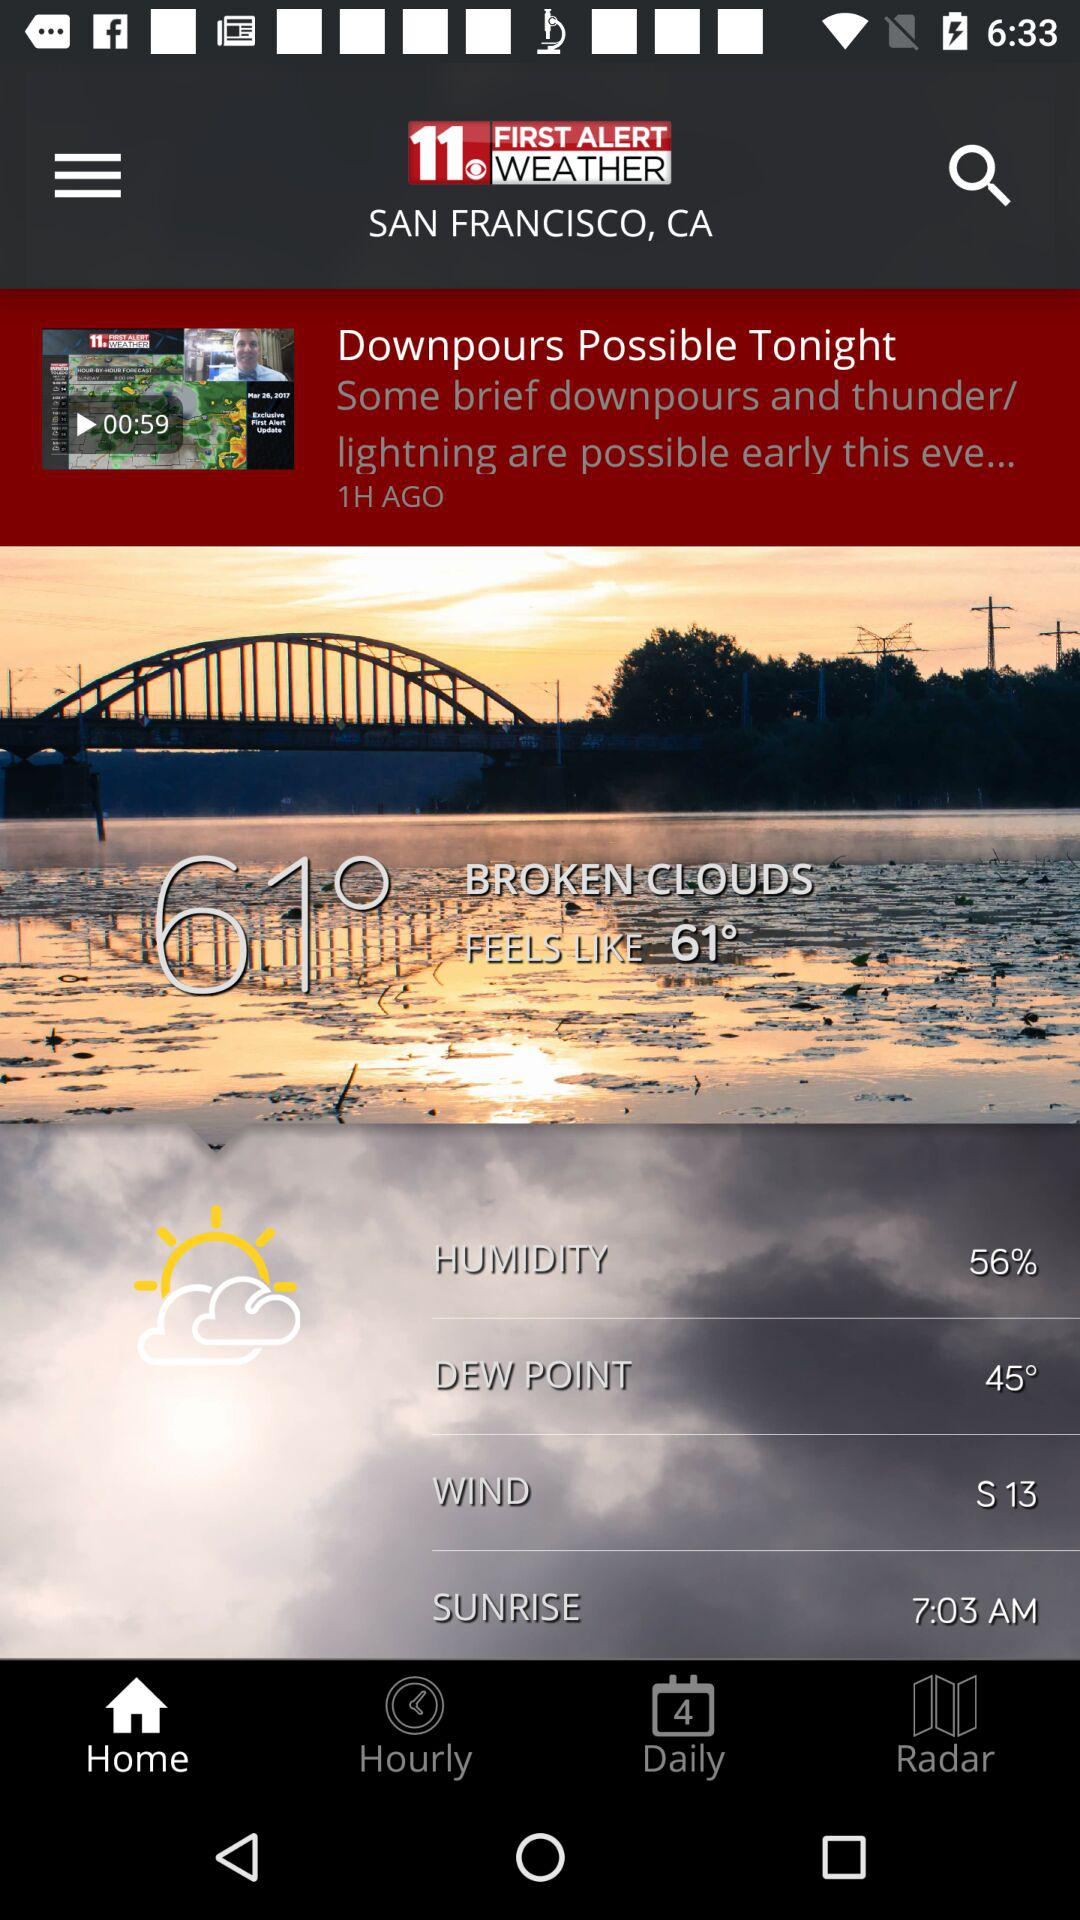How many minutes long is the video?
Answer the question using a single word or phrase. 00:59 